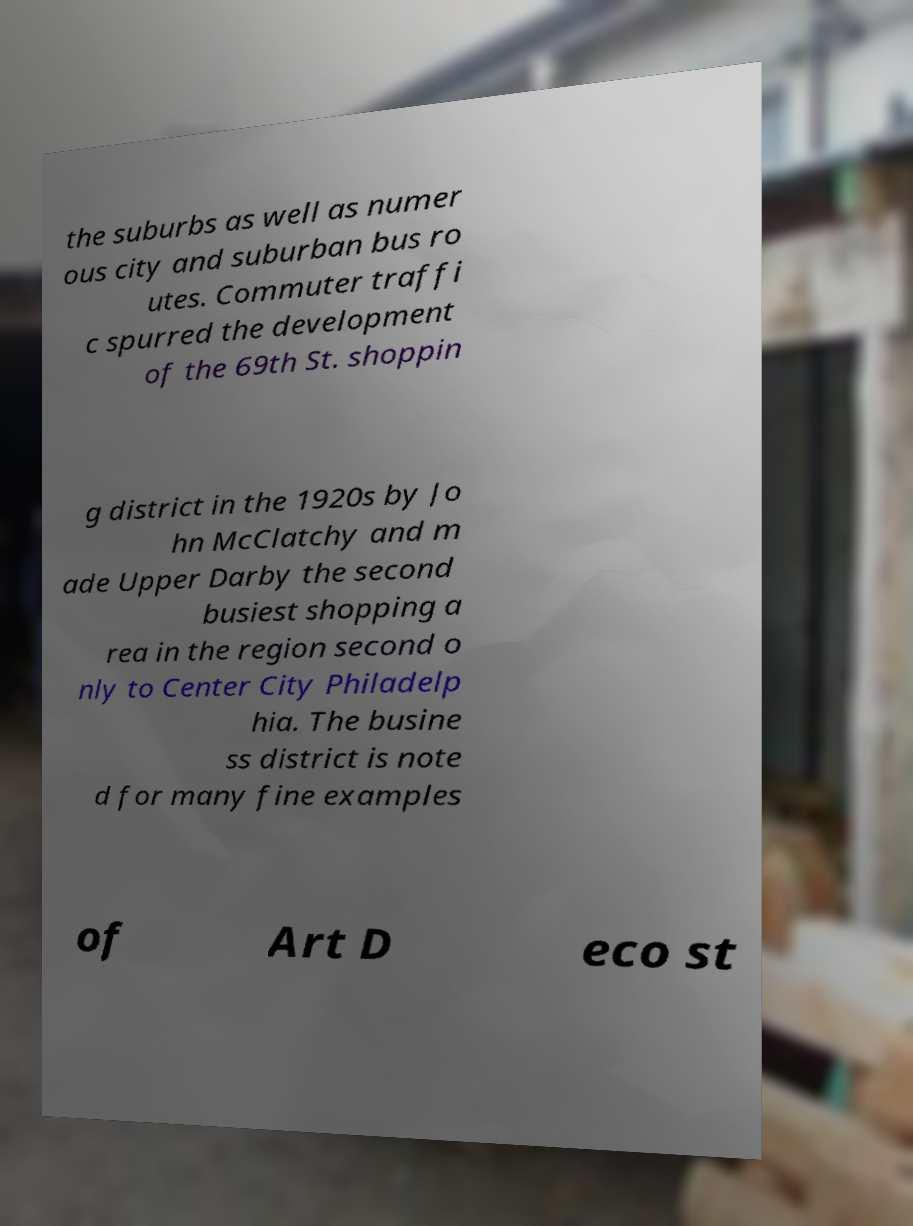Could you extract and type out the text from this image? the suburbs as well as numer ous city and suburban bus ro utes. Commuter traffi c spurred the development of the 69th St. shoppin g district in the 1920s by Jo hn McClatchy and m ade Upper Darby the second busiest shopping a rea in the region second o nly to Center City Philadelp hia. The busine ss district is note d for many fine examples of Art D eco st 